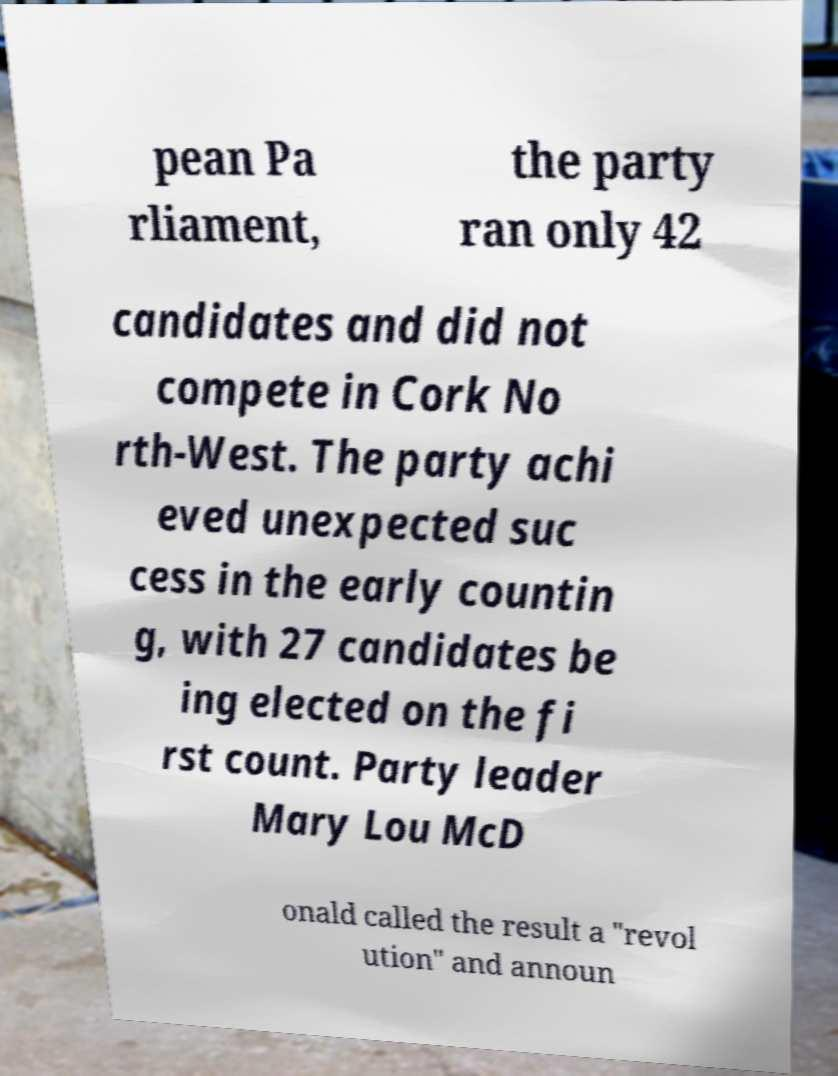I need the written content from this picture converted into text. Can you do that? pean Pa rliament, the party ran only 42 candidates and did not compete in Cork No rth-West. The party achi eved unexpected suc cess in the early countin g, with 27 candidates be ing elected on the fi rst count. Party leader Mary Lou McD onald called the result a "revol ution" and announ 